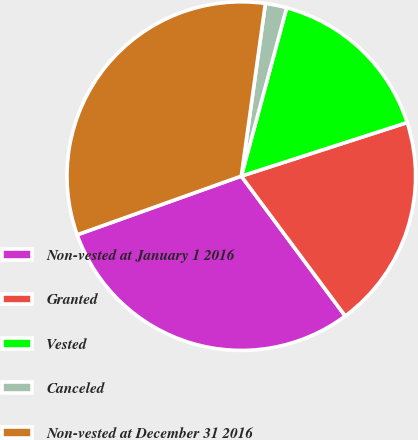Convert chart. <chart><loc_0><loc_0><loc_500><loc_500><pie_chart><fcel>Non-vested at January 1 2016<fcel>Granted<fcel>Vested<fcel>Canceled<fcel>Non-vested at December 31 2016<nl><fcel>29.7%<fcel>19.8%<fcel>15.84%<fcel>1.98%<fcel>32.67%<nl></chart> 